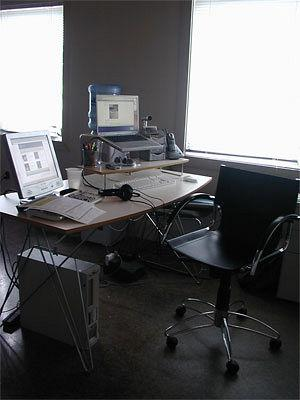This computer desk is in what type of building? office 